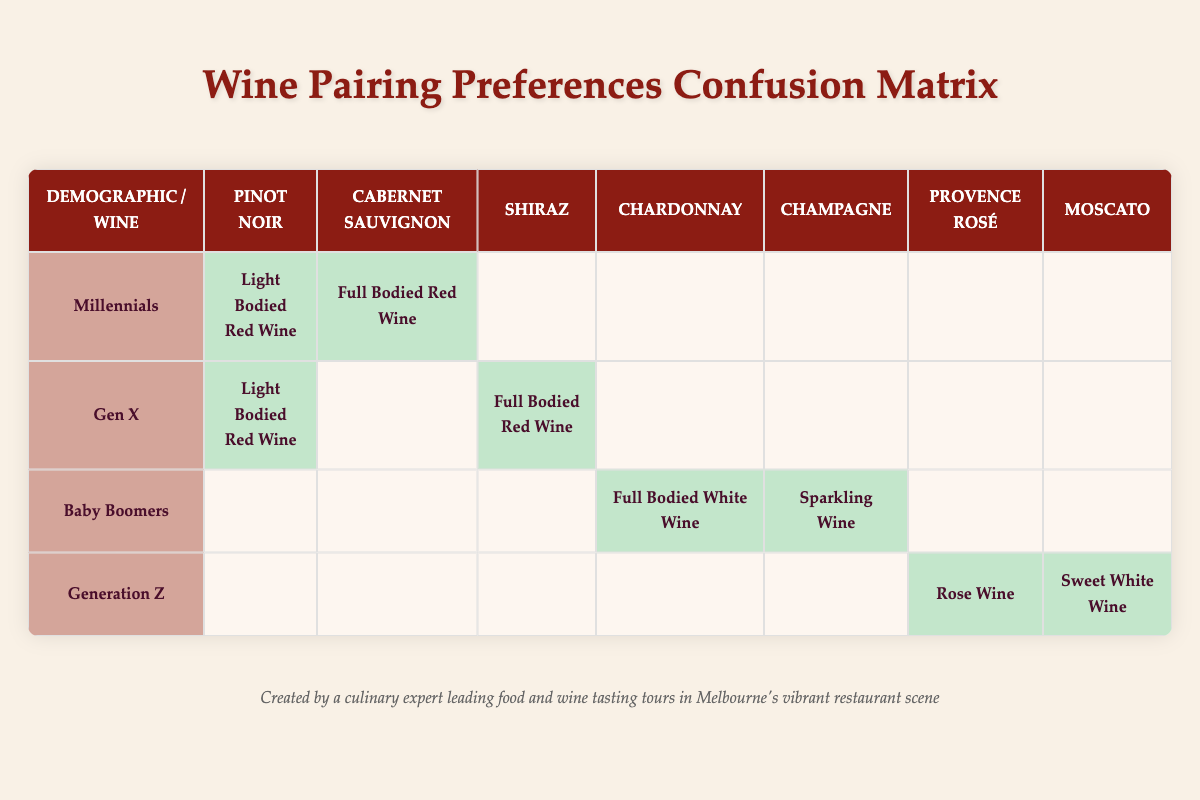What wine pairing do Millennials prefer for Light Bodied Red Wine? The table indicates that Millennials prefer "Light Bodied Red Wine," which is paired with "Pinot Noir."
Answer: Pinot Noir Which demographic prefers Shiraz as a wine pairing? According to the table, the only demographic group that prefers Shiraz is Gen X, as they have "Full Bodied Red Wine" which corresponds to Shiraz.
Answer: Gen X Do Baby Boomers prefer Sparkling Wine? Yes, the table shows that Baby Boomers have a preference for Sparkling Wine, with the actual pairing being Champagne.
Answer: Yes How many demographic groups prefer Sweet White Wine? The table reveals that only one demographic group, Generation Z, prefers Sweet White Wine, which corresponds to Moscato.
Answer: 1 What is the preferred wine for Baby Boomers when pairing with Full Bodied White Wine? Baby Boomers prefer "Full Bodied White Wine," which in the table is paired with "Chardonnay."
Answer: Chardonnay Which demographic shows no preference for Pinot Noir? By looking at the table, we see that Baby Boomers and Generation Z do not have a preference for Pinot Noir; it is only preferred by Millennials and Gen X.
Answer: Baby Boomers and Generation Z Which wine has the most preferences among the demographic groups listed? Focusing on the preferred wine pairings in the table, both "Light Bodied Red Wine" with Pinot Noir and "Full Bodied Red Wine" with Shiraz have preferences from Gen X and Millennials. However, if we consider unique mentions, then no wine stands out in preferences among all demographics. The actual pairings differ and need more consideration for aggregate preference counts.
Answer: None specifically stands out How many total preferences are indicated for each demographic group? To determine the total preferences, we can count the preferred pairings for each demographic: Millennials have 2, Gen X has 2, Baby Boomers have 2, and Generation Z has 2, so there are 8 total preferences indicated across all groups.
Answer: 8 